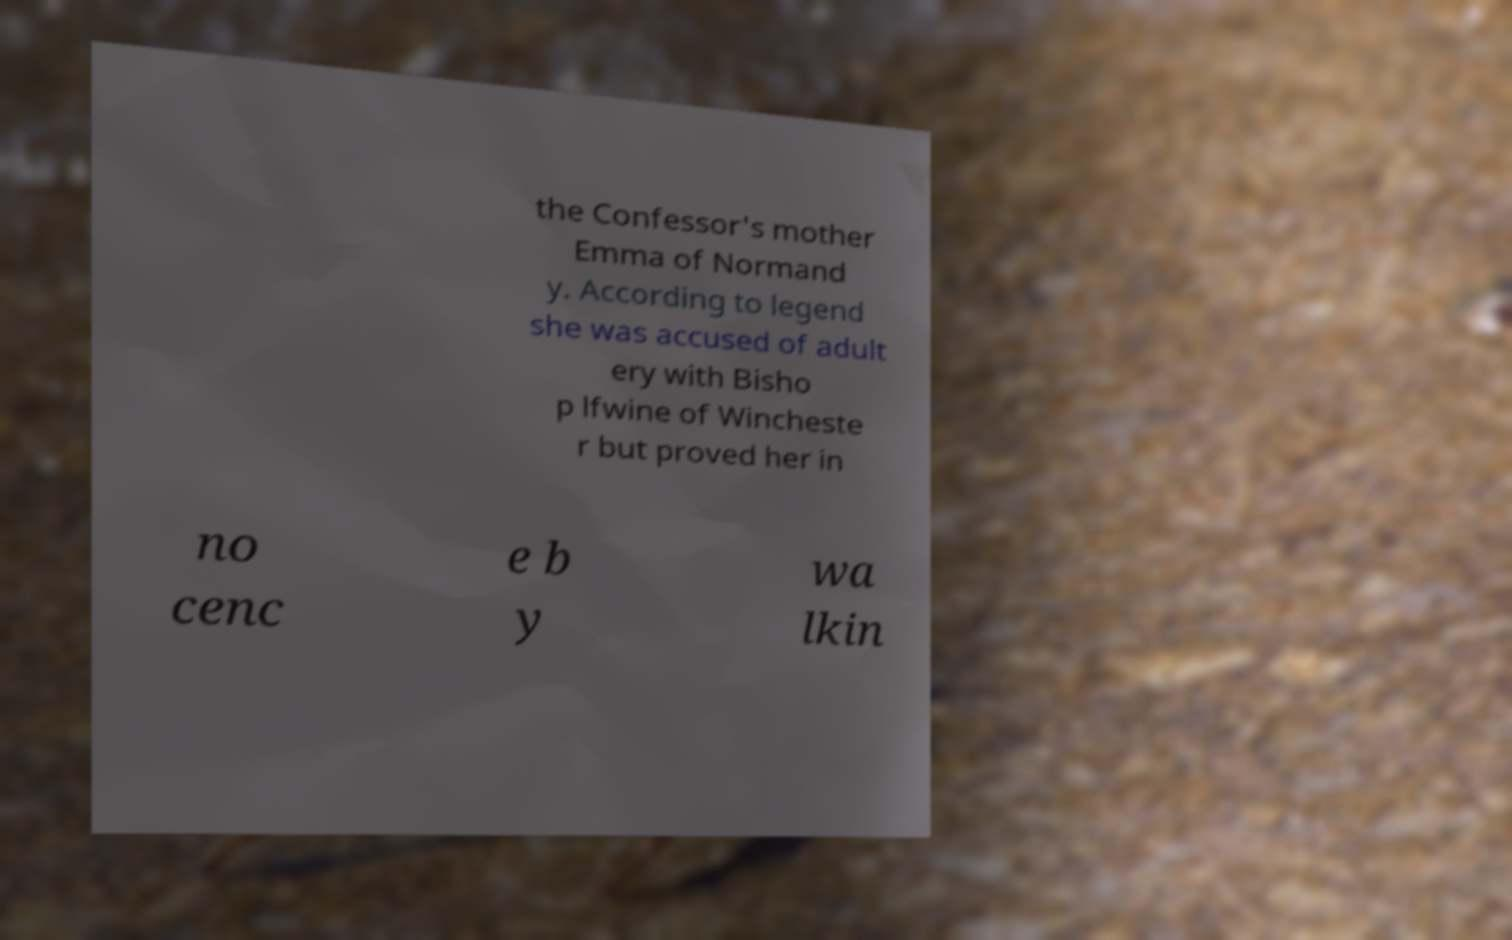Can you read and provide the text displayed in the image?This photo seems to have some interesting text. Can you extract and type it out for me? the Confessor's mother Emma of Normand y. According to legend she was accused of adult ery with Bisho p lfwine of Wincheste r but proved her in no cenc e b y wa lkin 